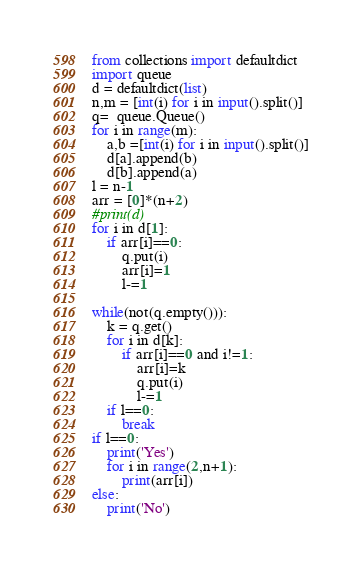<code> <loc_0><loc_0><loc_500><loc_500><_Python_>from collections import defaultdict
import queue
d = defaultdict(list)
n,m = [int(i) for i in input().split()]
q=  queue.Queue()
for i in range(m):
    a,b =[int(i) for i in input().split()]
    d[a].append(b)
    d[b].append(a)
l = n-1
arr = [0]*(n+2)
#print(d)
for i in d[1]:
    if arr[i]==0:
        q.put(i)
        arr[i]=1
        l-=1
    
while(not(q.empty())):
    k = q.get()
    for i in d[k]:
        if arr[i]==0 and i!=1:
            arr[i]=k
            q.put(i)
            l-=1
    if l==0:
        break
if l==0:
    print('Yes')
    for i in range(2,n+1):
        print(arr[i])
else:
    print('No')</code> 